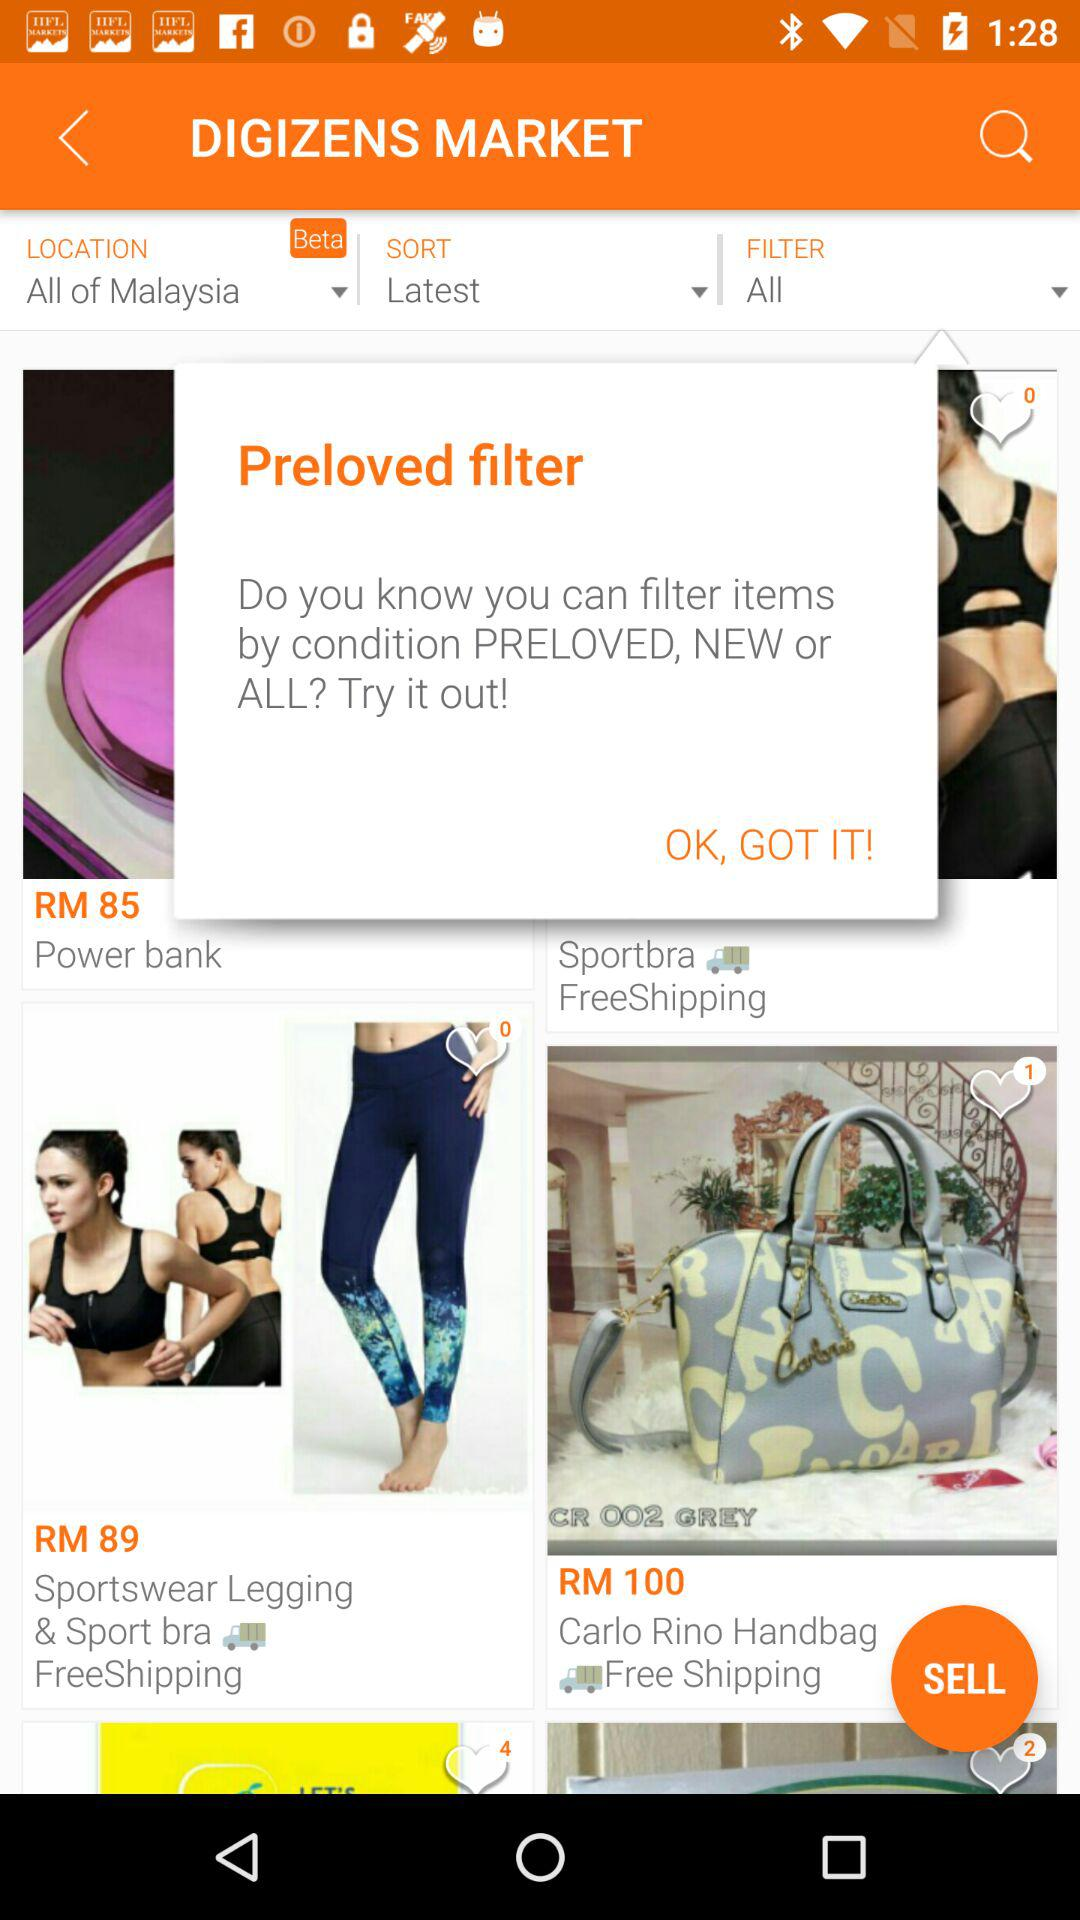What is the price of the handbag? The price of the handbag is RM 100. 